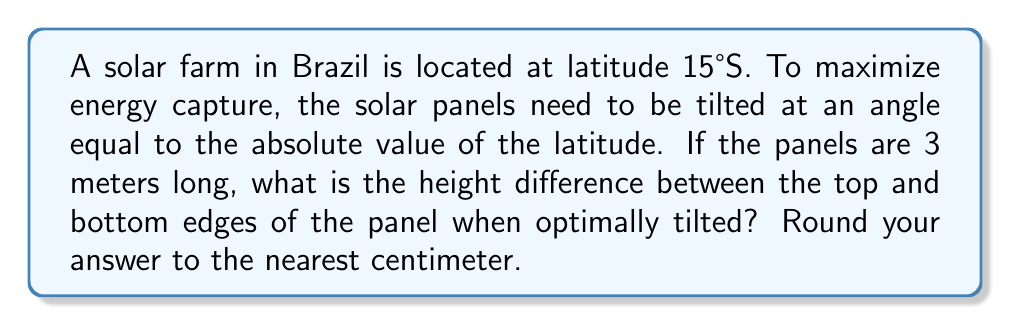Can you answer this question? Let's approach this step-by-step:

1) The optimal tilt angle is equal to the absolute value of the latitude:
   $\theta = |15°| = 15°$

2) We can visualize this as a right triangle, where:
   - The hypotenuse is the length of the panel (3 meters)
   - The angle between the ground and the panel is 15°
   - We need to find the opposite side of this angle (the height difference)

3) We can use the sine function to find this height:
   $\sin(\theta) = \frac{\text{opposite}}{\text{hypotenuse}}$

4) Rearranging this equation:
   $\text{opposite} = \text{hypotenuse} \times \sin(\theta)$

5) Plugging in our values:
   $\text{height} = 3 \times \sin(15°)$

6) Calculate:
   $\text{height} = 3 \times 0.2588 = 0.7764 \text{ meters}$

7) Convert to centimeters and round to the nearest cm:
   $0.7764 \text{ meters} = 77.64 \text{ cm} \approx 78 \text{ cm}$

[asy]
import geometry;

size(200);
pair A=(0,0), B=(100,0), C=(100,26.79);
draw(A--B--C--A);
draw(rightanglemark(A,B,C,20));
label("3 m",B--C,E);
label("15°",A,SW);
label("h",C,E);
[/asy]
Answer: 78 cm 